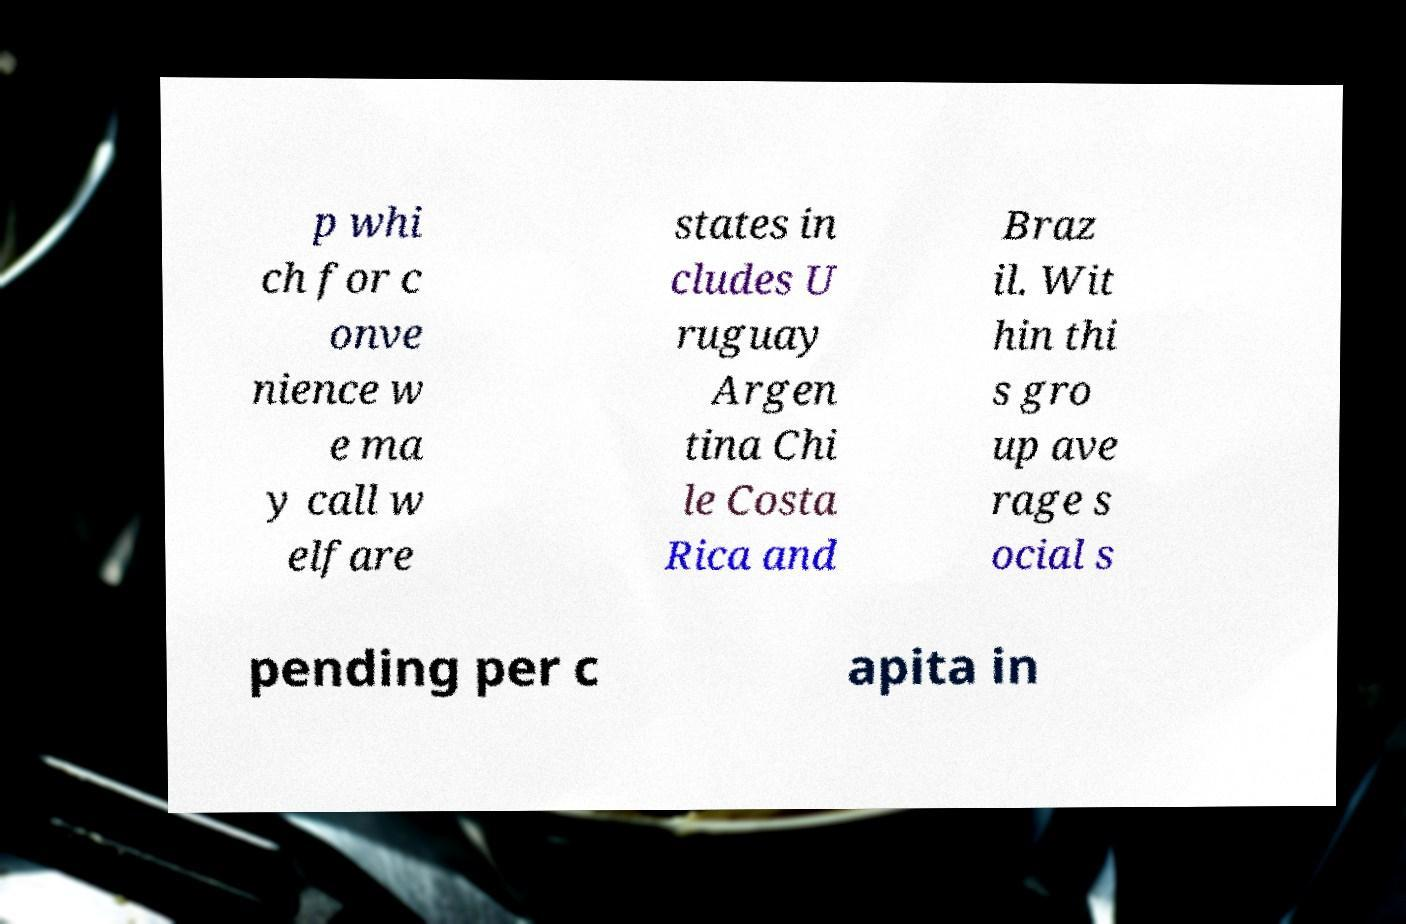I need the written content from this picture converted into text. Can you do that? p whi ch for c onve nience w e ma y call w elfare states in cludes U ruguay Argen tina Chi le Costa Rica and Braz il. Wit hin thi s gro up ave rage s ocial s pending per c apita in 